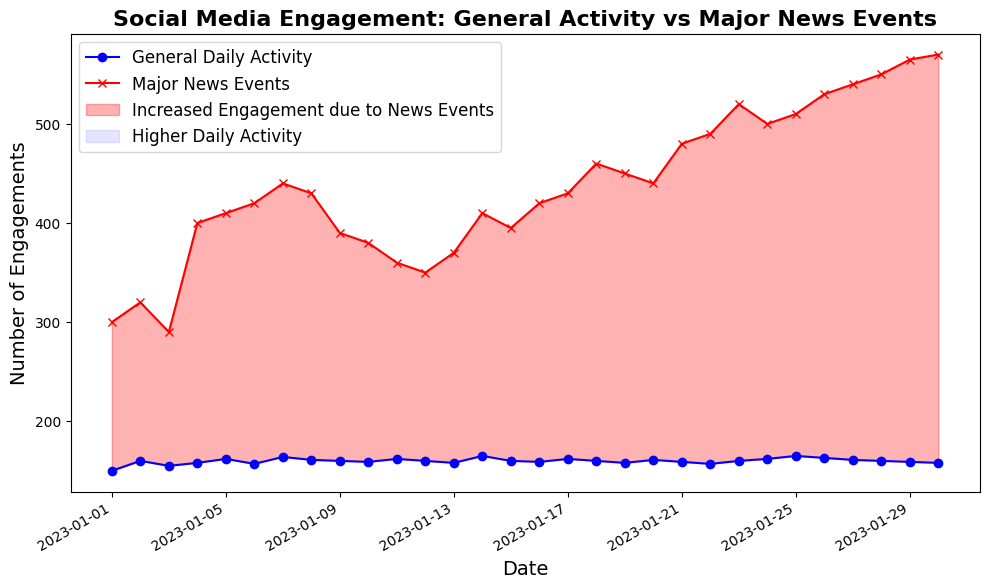What's the overall trend for social media engagement during major news events? The line plot shows an increasing trend for social media engagement during major news events, with the number of engagements rising from 300 on January 1st to 570 on January 30th. There are fluctuations, but the overall direction is upward.
Answer: Upward trend How does the general daily activity compare to major news events on January 25th? On January 25th, the general daily activity is 165, whereas the major news events engagement is 510. By comparing the two values directly from the plot, we see that major news events have a higher engagement.
Answer: Major news events have higher engagement Where is the difference between daily activity and major news events the largest? The largest difference can be identified by looking for the widest gap between the two lines on the plot. This appears to occur on January 30th, where the general daily activity is 158 and the major news events engagement is 570, giving a difference of 412.
Answer: January 30th Between which dates does the engagement due to major news events first surpass 400? By looking at the point where the red line representing major news events first crosses the 400 engagements mark, it happens on January 4th. Comparing to previous and following dates, it maintains and surpasses 400 from January 5th onwards.
Answer: January 4th What is the average engagement for major news events from January 20th to January 26th? To find this, sum the values of major news events from January 20th (440) to January 26th (530) and then divide by the number of days (7). The calculation is (440 + 480 + 490 + 520 + 500 + 510 + 530) / 7 = 3470 / 7 = 495.71.
Answer: 495.71 During which period does the engagement due to major news events appear to be consistently high? By examining the plot, it's clear that from January 18th onwards until the end of the month, engagement levels for major news events stay consistently above 450.
Answer: January 18th to January 30th What can be inferred about general daily activity compared to major news events on January 7th? On January 7th, the plot shows general daily activity at 164 and major news events at 440. The general daily activity is significantly lower compared to major news events engagement on this date.
Answer: Lower general daily activity How often do general daily activities appear to surpass 160 engagements during the month? By scanning the plot, general daily activities surpass 160 engagements on January 2nd, January 4th, January 5th, January 7th, January 8th, January 11th, January 14th, January 17th, January 24th, and January 25th, making it 10 days in total.
Answer: 10 days When does the fill between the two lines indicate an increased engagement due to news events first appear? The red-shaded area indicating increased engagement due to news events first appears on January 1st itself, where major news events engagement is higher than general daily activity.
Answer: January 1st 